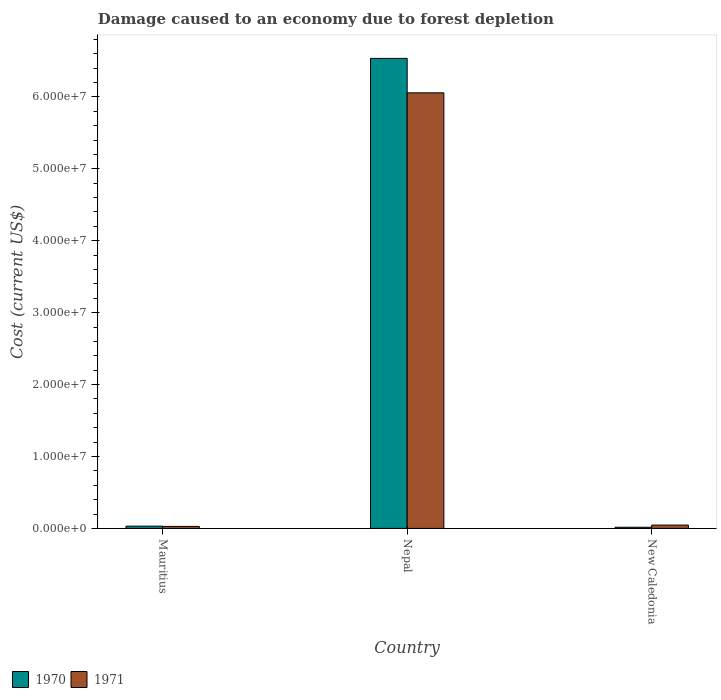How many groups of bars are there?
Provide a short and direct response. 3. Are the number of bars on each tick of the X-axis equal?
Your answer should be very brief. Yes. How many bars are there on the 2nd tick from the right?
Provide a succinct answer. 2. What is the label of the 3rd group of bars from the left?
Your response must be concise. New Caledonia. In how many cases, is the number of bars for a given country not equal to the number of legend labels?
Provide a succinct answer. 0. What is the cost of damage caused due to forest depletion in 1971 in Nepal?
Ensure brevity in your answer.  6.06e+07. Across all countries, what is the maximum cost of damage caused due to forest depletion in 1970?
Your response must be concise. 6.54e+07. Across all countries, what is the minimum cost of damage caused due to forest depletion in 1970?
Give a very brief answer. 1.60e+05. In which country was the cost of damage caused due to forest depletion in 1971 maximum?
Provide a succinct answer. Nepal. In which country was the cost of damage caused due to forest depletion in 1971 minimum?
Make the answer very short. Mauritius. What is the total cost of damage caused due to forest depletion in 1971 in the graph?
Provide a succinct answer. 6.13e+07. What is the difference between the cost of damage caused due to forest depletion in 1971 in Mauritius and that in Nepal?
Your response must be concise. -6.03e+07. What is the difference between the cost of damage caused due to forest depletion in 1970 in New Caledonia and the cost of damage caused due to forest depletion in 1971 in Mauritius?
Make the answer very short. -1.19e+05. What is the average cost of damage caused due to forest depletion in 1970 per country?
Provide a short and direct response. 2.19e+07. What is the difference between the cost of damage caused due to forest depletion of/in 1970 and cost of damage caused due to forest depletion of/in 1971 in New Caledonia?
Your answer should be compact. -3.05e+05. In how many countries, is the cost of damage caused due to forest depletion in 1970 greater than 36000000 US$?
Make the answer very short. 1. What is the ratio of the cost of damage caused due to forest depletion in 1971 in Mauritius to that in Nepal?
Give a very brief answer. 0. What is the difference between the highest and the second highest cost of damage caused due to forest depletion in 1970?
Provide a short and direct response. -6.52e+07. What is the difference between the highest and the lowest cost of damage caused due to forest depletion in 1971?
Your response must be concise. 6.03e+07. Is the sum of the cost of damage caused due to forest depletion in 1970 in Mauritius and Nepal greater than the maximum cost of damage caused due to forest depletion in 1971 across all countries?
Offer a terse response. Yes. How many bars are there?
Offer a terse response. 6. Are all the bars in the graph horizontal?
Your answer should be compact. No. What is the difference between two consecutive major ticks on the Y-axis?
Your answer should be very brief. 1.00e+07. Are the values on the major ticks of Y-axis written in scientific E-notation?
Ensure brevity in your answer.  Yes. Does the graph contain any zero values?
Offer a terse response. No. Where does the legend appear in the graph?
Make the answer very short. Bottom left. How many legend labels are there?
Offer a very short reply. 2. What is the title of the graph?
Make the answer very short. Damage caused to an economy due to forest depletion. What is the label or title of the X-axis?
Provide a succinct answer. Country. What is the label or title of the Y-axis?
Provide a short and direct response. Cost (current US$). What is the Cost (current US$) of 1970 in Mauritius?
Keep it short and to the point. 3.14e+05. What is the Cost (current US$) of 1971 in Mauritius?
Provide a succinct answer. 2.78e+05. What is the Cost (current US$) of 1970 in Nepal?
Give a very brief answer. 6.54e+07. What is the Cost (current US$) in 1971 in Nepal?
Your response must be concise. 6.06e+07. What is the Cost (current US$) in 1970 in New Caledonia?
Offer a terse response. 1.60e+05. What is the Cost (current US$) of 1971 in New Caledonia?
Your answer should be very brief. 4.65e+05. Across all countries, what is the maximum Cost (current US$) in 1970?
Ensure brevity in your answer.  6.54e+07. Across all countries, what is the maximum Cost (current US$) of 1971?
Make the answer very short. 6.06e+07. Across all countries, what is the minimum Cost (current US$) of 1970?
Offer a very short reply. 1.60e+05. Across all countries, what is the minimum Cost (current US$) of 1971?
Provide a succinct answer. 2.78e+05. What is the total Cost (current US$) in 1970 in the graph?
Keep it short and to the point. 6.58e+07. What is the total Cost (current US$) in 1971 in the graph?
Provide a short and direct response. 6.13e+07. What is the difference between the Cost (current US$) of 1970 in Mauritius and that in Nepal?
Offer a terse response. -6.50e+07. What is the difference between the Cost (current US$) of 1971 in Mauritius and that in Nepal?
Provide a succinct answer. -6.03e+07. What is the difference between the Cost (current US$) in 1970 in Mauritius and that in New Caledonia?
Give a very brief answer. 1.54e+05. What is the difference between the Cost (current US$) of 1971 in Mauritius and that in New Caledonia?
Ensure brevity in your answer.  -1.87e+05. What is the difference between the Cost (current US$) of 1970 in Nepal and that in New Caledonia?
Keep it short and to the point. 6.52e+07. What is the difference between the Cost (current US$) of 1971 in Nepal and that in New Caledonia?
Your answer should be very brief. 6.01e+07. What is the difference between the Cost (current US$) in 1970 in Mauritius and the Cost (current US$) in 1971 in Nepal?
Offer a terse response. -6.02e+07. What is the difference between the Cost (current US$) in 1970 in Mauritius and the Cost (current US$) in 1971 in New Caledonia?
Your response must be concise. -1.52e+05. What is the difference between the Cost (current US$) of 1970 in Nepal and the Cost (current US$) of 1971 in New Caledonia?
Make the answer very short. 6.49e+07. What is the average Cost (current US$) in 1970 per country?
Your response must be concise. 2.19e+07. What is the average Cost (current US$) of 1971 per country?
Give a very brief answer. 2.04e+07. What is the difference between the Cost (current US$) in 1970 and Cost (current US$) in 1971 in Mauritius?
Your response must be concise. 3.52e+04. What is the difference between the Cost (current US$) of 1970 and Cost (current US$) of 1971 in Nepal?
Your response must be concise. 4.79e+06. What is the difference between the Cost (current US$) of 1970 and Cost (current US$) of 1971 in New Caledonia?
Make the answer very short. -3.05e+05. What is the ratio of the Cost (current US$) of 1970 in Mauritius to that in Nepal?
Your answer should be very brief. 0. What is the ratio of the Cost (current US$) in 1971 in Mauritius to that in Nepal?
Keep it short and to the point. 0. What is the ratio of the Cost (current US$) of 1970 in Mauritius to that in New Caledonia?
Keep it short and to the point. 1.96. What is the ratio of the Cost (current US$) of 1971 in Mauritius to that in New Caledonia?
Offer a very short reply. 0.6. What is the ratio of the Cost (current US$) in 1970 in Nepal to that in New Caledonia?
Ensure brevity in your answer.  409.45. What is the ratio of the Cost (current US$) of 1971 in Nepal to that in New Caledonia?
Provide a succinct answer. 130.21. What is the difference between the highest and the second highest Cost (current US$) in 1970?
Keep it short and to the point. 6.50e+07. What is the difference between the highest and the second highest Cost (current US$) in 1971?
Your answer should be compact. 6.01e+07. What is the difference between the highest and the lowest Cost (current US$) of 1970?
Provide a succinct answer. 6.52e+07. What is the difference between the highest and the lowest Cost (current US$) of 1971?
Provide a short and direct response. 6.03e+07. 